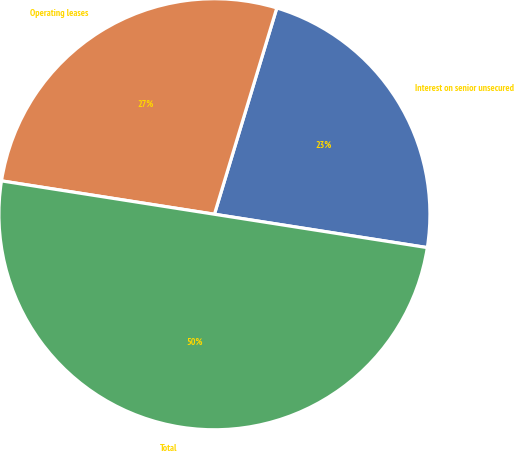Convert chart. <chart><loc_0><loc_0><loc_500><loc_500><pie_chart><fcel>Interest on senior unsecured<fcel>Operating leases<fcel>Total<nl><fcel>22.8%<fcel>27.2%<fcel>50.0%<nl></chart> 